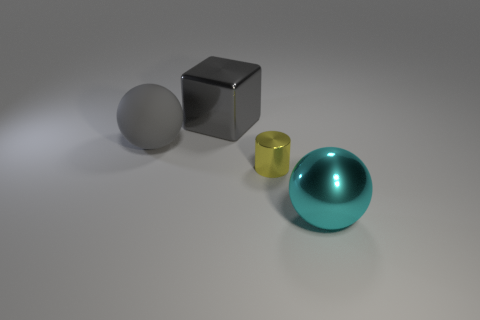Is there any other thing that is the same material as the large gray sphere?
Keep it short and to the point. No. Is there a purple metallic thing that has the same shape as the rubber object?
Make the answer very short. No. What material is the large cube that is the same color as the matte thing?
Give a very brief answer. Metal. What number of matte things are small yellow cylinders or big yellow cylinders?
Give a very brief answer. 0. The yellow shiny thing has what shape?
Your answer should be compact. Cylinder. What number of other things are made of the same material as the yellow object?
Your response must be concise. 2. The ball that is the same material as the tiny yellow cylinder is what color?
Make the answer very short. Cyan. Is the size of the cube that is behind the metal sphere the same as the tiny cylinder?
Provide a succinct answer. No. The big metal object that is the same shape as the large gray matte thing is what color?
Offer a terse response. Cyan. What shape is the big shiny thing that is in front of the yellow cylinder in front of the gray sphere behind the shiny cylinder?
Your response must be concise. Sphere. 